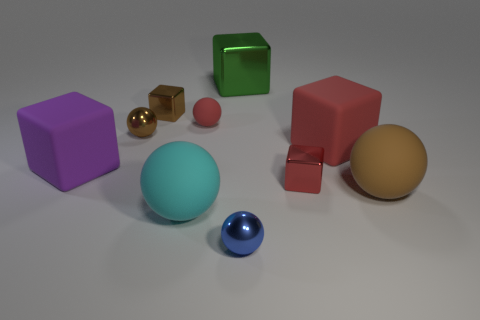Can you describe the lighting and shadows in the scene? The lighting in the scene appears to be diffused with soft shadows, suggesting an overcast or studio-lighting setup. The shadows are mostly subtle and beneath the objects, which helps define their forms and positions in the three-dimensional space. 